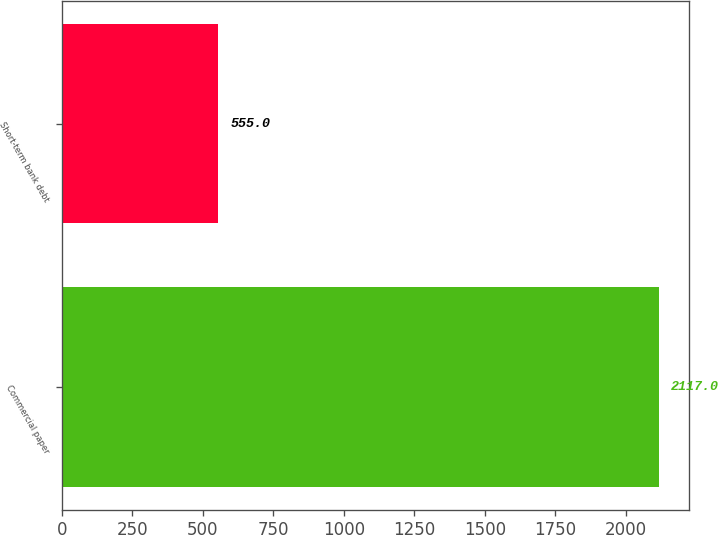Convert chart. <chart><loc_0><loc_0><loc_500><loc_500><bar_chart><fcel>Commercial paper<fcel>Short-term bank debt<nl><fcel>2117<fcel>555<nl></chart> 